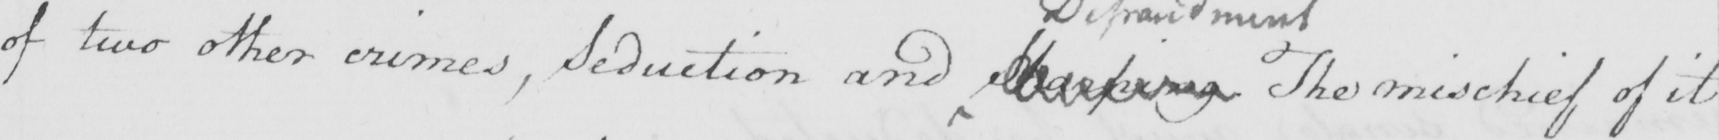What is written in this line of handwriting? of two other crimes , Seduction and  <gap/>  The mischief of it 